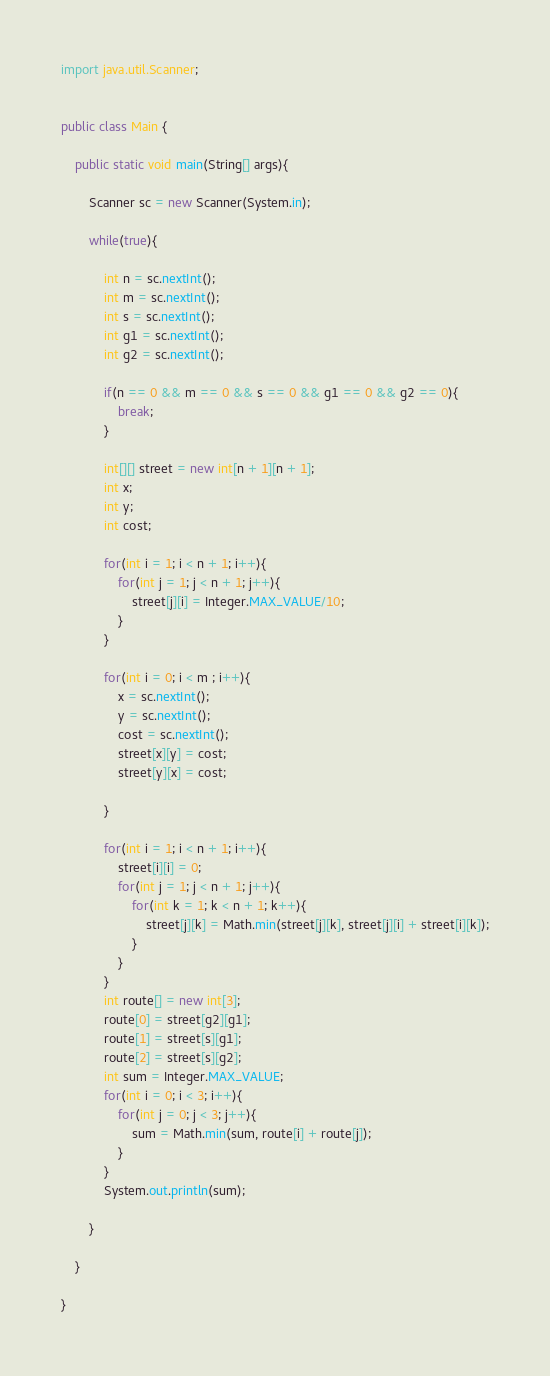<code> <loc_0><loc_0><loc_500><loc_500><_Java_>import java.util.Scanner;


public class Main {
	
	public static void main(String[] args){
		
		Scanner sc = new Scanner(System.in);
		
		while(true){
			
			int n = sc.nextInt();
			int m = sc.nextInt();
			int s = sc.nextInt();
			int g1 = sc.nextInt();
			int g2 = sc.nextInt();
			
			if(n == 0 && m == 0 && s == 0 && g1 == 0 && g2 == 0){
				break;
			}
			
			int[][] street = new int[n + 1][n + 1];
			int x;
			int y;
			int cost;
			
			for(int i = 1; i < n + 1; i++){
				for(int j = 1; j < n + 1; j++){
					street[j][i] = Integer.MAX_VALUE/10;
				}
			}
			
			for(int i = 0; i < m ; i++){
				x = sc.nextInt();
				y = sc.nextInt();
				cost = sc.nextInt();
				street[x][y] = cost;
				street[y][x] = cost;
				
			}
			
			for(int i = 1; i < n + 1; i++){
				street[i][i] = 0;
				for(int j = 1; j < n + 1; j++){
					for(int k = 1; k < n + 1; k++){
						street[j][k] = Math.min(street[j][k], street[j][i] + street[i][k]);
					}
				}
			}
			int route[] = new int[3];
			route[0] = street[g2][g1];
			route[1] = street[s][g1];
			route[2] = street[s][g2];
			int sum = Integer.MAX_VALUE;
			for(int i = 0; i < 3; i++){
				for(int j = 0; j < 3; j++){
					sum = Math.min(sum, route[i] + route[j]);
				}
			}
			System.out.println(sum);
			
		}
		
	}

}</code> 